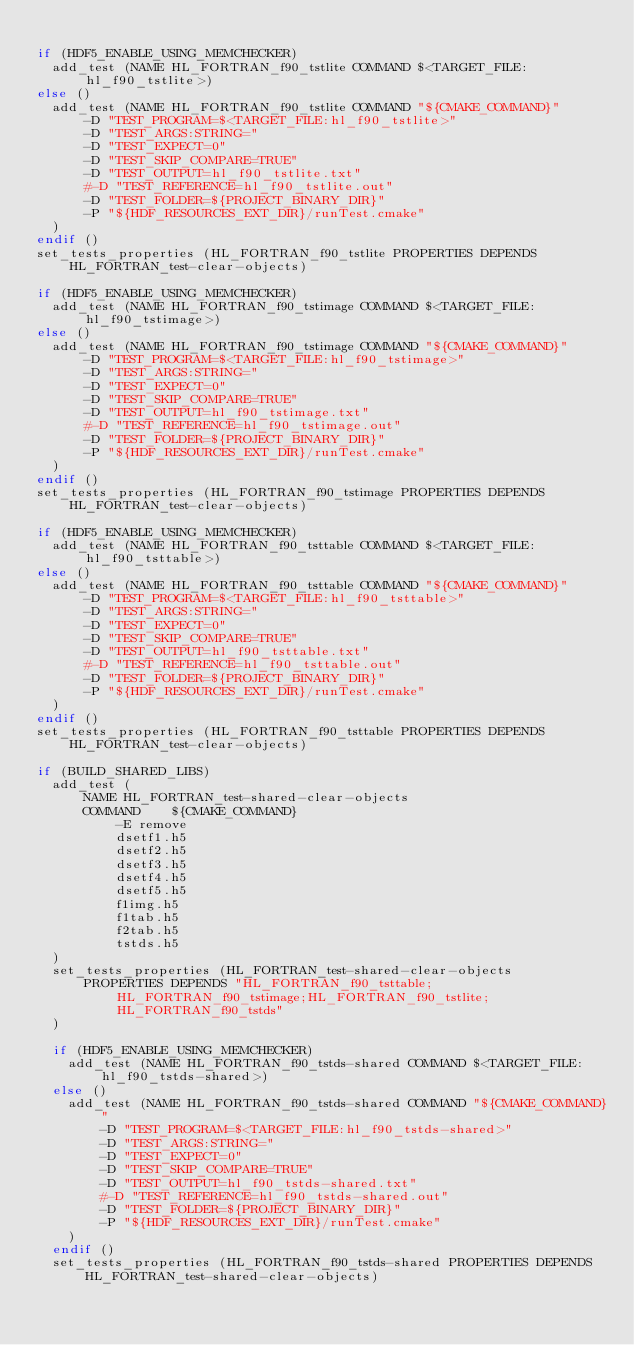Convert code to text. <code><loc_0><loc_0><loc_500><loc_500><_CMake_>
if (HDF5_ENABLE_USING_MEMCHECKER)
  add_test (NAME HL_FORTRAN_f90_tstlite COMMAND $<TARGET_FILE:hl_f90_tstlite>)
else ()
  add_test (NAME HL_FORTRAN_f90_tstlite COMMAND "${CMAKE_COMMAND}"
      -D "TEST_PROGRAM=$<TARGET_FILE:hl_f90_tstlite>"
      -D "TEST_ARGS:STRING="
      -D "TEST_EXPECT=0"
      -D "TEST_SKIP_COMPARE=TRUE"
      -D "TEST_OUTPUT=hl_f90_tstlite.txt"
      #-D "TEST_REFERENCE=hl_f90_tstlite.out"
      -D "TEST_FOLDER=${PROJECT_BINARY_DIR}"
      -P "${HDF_RESOURCES_EXT_DIR}/runTest.cmake"
  )
endif ()
set_tests_properties (HL_FORTRAN_f90_tstlite PROPERTIES DEPENDS HL_FORTRAN_test-clear-objects)

if (HDF5_ENABLE_USING_MEMCHECKER)
  add_test (NAME HL_FORTRAN_f90_tstimage COMMAND $<TARGET_FILE:hl_f90_tstimage>)
else ()
  add_test (NAME HL_FORTRAN_f90_tstimage COMMAND "${CMAKE_COMMAND}"
      -D "TEST_PROGRAM=$<TARGET_FILE:hl_f90_tstimage>"
      -D "TEST_ARGS:STRING="
      -D "TEST_EXPECT=0"
      -D "TEST_SKIP_COMPARE=TRUE"
      -D "TEST_OUTPUT=hl_f90_tstimage.txt"
      #-D "TEST_REFERENCE=hl_f90_tstimage.out"
      -D "TEST_FOLDER=${PROJECT_BINARY_DIR}"
      -P "${HDF_RESOURCES_EXT_DIR}/runTest.cmake"
  )
endif ()
set_tests_properties (HL_FORTRAN_f90_tstimage PROPERTIES DEPENDS HL_FORTRAN_test-clear-objects)

if (HDF5_ENABLE_USING_MEMCHECKER)
  add_test (NAME HL_FORTRAN_f90_tsttable COMMAND $<TARGET_FILE:hl_f90_tsttable>)
else ()
  add_test (NAME HL_FORTRAN_f90_tsttable COMMAND "${CMAKE_COMMAND}"
      -D "TEST_PROGRAM=$<TARGET_FILE:hl_f90_tsttable>"
      -D "TEST_ARGS:STRING="
      -D "TEST_EXPECT=0"
      -D "TEST_SKIP_COMPARE=TRUE"
      -D "TEST_OUTPUT=hl_f90_tsttable.txt"
      #-D "TEST_REFERENCE=hl_f90_tsttable.out"
      -D "TEST_FOLDER=${PROJECT_BINARY_DIR}"
      -P "${HDF_RESOURCES_EXT_DIR}/runTest.cmake"
  )
endif ()
set_tests_properties (HL_FORTRAN_f90_tsttable PROPERTIES DEPENDS HL_FORTRAN_test-clear-objects)

if (BUILD_SHARED_LIBS)
  add_test (
      NAME HL_FORTRAN_test-shared-clear-objects
      COMMAND    ${CMAKE_COMMAND}
          -E remove
          dsetf1.h5
          dsetf2.h5
          dsetf3.h5
          dsetf4.h5
          dsetf5.h5
          f1img.h5
          f1tab.h5
          f2tab.h5
          tstds.h5
  )
  set_tests_properties (HL_FORTRAN_test-shared-clear-objects
      PROPERTIES DEPENDS "HL_FORTRAN_f90_tsttable;HL_FORTRAN_f90_tstimage;HL_FORTRAN_f90_tstlite;HL_FORTRAN_f90_tstds"
  )

  if (HDF5_ENABLE_USING_MEMCHECKER)
    add_test (NAME HL_FORTRAN_f90_tstds-shared COMMAND $<TARGET_FILE:hl_f90_tstds-shared>)
  else ()
    add_test (NAME HL_FORTRAN_f90_tstds-shared COMMAND "${CMAKE_COMMAND}"
        -D "TEST_PROGRAM=$<TARGET_FILE:hl_f90_tstds-shared>"
        -D "TEST_ARGS:STRING="
        -D "TEST_EXPECT=0"
        -D "TEST_SKIP_COMPARE=TRUE"
        -D "TEST_OUTPUT=hl_f90_tstds-shared.txt"
        #-D "TEST_REFERENCE=hl_f90_tstds-shared.out"
        -D "TEST_FOLDER=${PROJECT_BINARY_DIR}"
        -P "${HDF_RESOURCES_EXT_DIR}/runTest.cmake"
    )
  endif ()
  set_tests_properties (HL_FORTRAN_f90_tstds-shared PROPERTIES DEPENDS HL_FORTRAN_test-shared-clear-objects)
</code> 